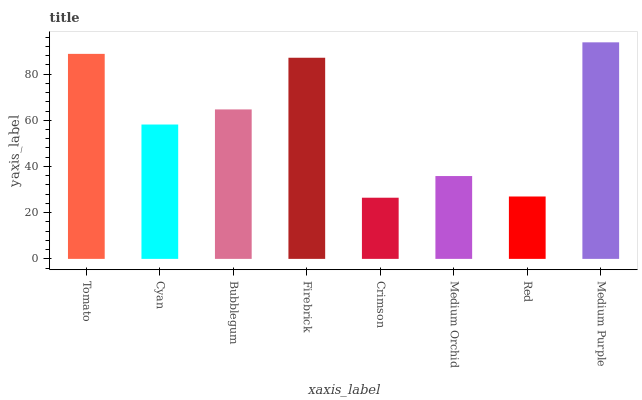Is Crimson the minimum?
Answer yes or no. Yes. Is Medium Purple the maximum?
Answer yes or no. Yes. Is Cyan the minimum?
Answer yes or no. No. Is Cyan the maximum?
Answer yes or no. No. Is Tomato greater than Cyan?
Answer yes or no. Yes. Is Cyan less than Tomato?
Answer yes or no. Yes. Is Cyan greater than Tomato?
Answer yes or no. No. Is Tomato less than Cyan?
Answer yes or no. No. Is Bubblegum the high median?
Answer yes or no. Yes. Is Cyan the low median?
Answer yes or no. Yes. Is Firebrick the high median?
Answer yes or no. No. Is Red the low median?
Answer yes or no. No. 